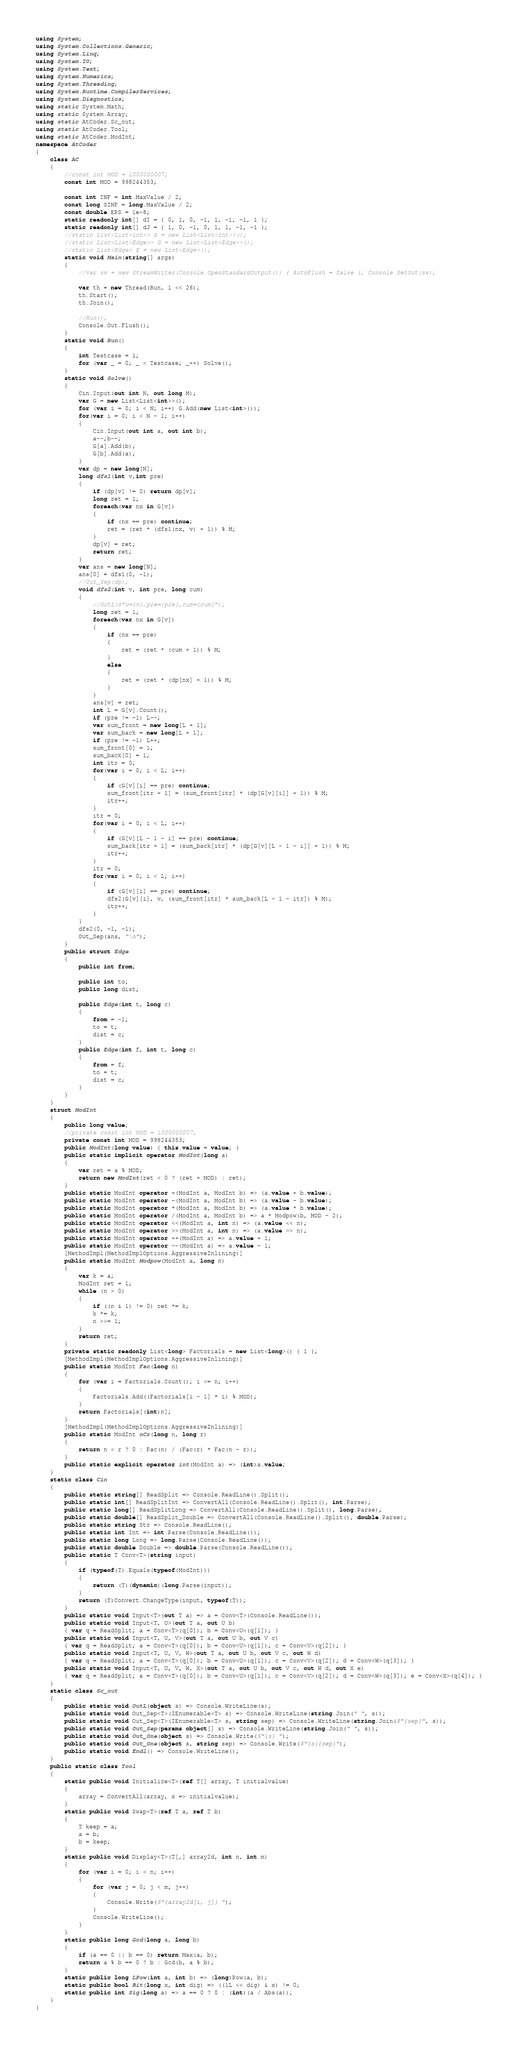Convert code to text. <code><loc_0><loc_0><loc_500><loc_500><_C#_>using System;
using System.Collections.Generic;
using System.Linq;
using System.IO;
using System.Text;
using System.Numerics;
using System.Threading;
using System.Runtime.CompilerServices;
using System.Diagnostics;
using static System.Math;
using static System.Array;
using static AtCoder.Sc_out;
using static AtCoder.Tool;
using static AtCoder.ModInt;
namespace AtCoder
{
    class AC
    {
        //const int MOD = 1000000007;
        const int MOD = 998244353;

        const int INF = int.MaxValue / 2;
        const long SINF = long.MaxValue / 2;
        const double EPS = 1e-8;
        static readonly int[] dI = { 0, 1, 0, -1, 1, -1, -1, 1 };
        static readonly int[] dJ = { 1, 0, -1, 0, 1, 1, -1, -1 };
        //static List<List<int>> G = new List<List<int>>();
        //static List<List<Edge>> G = new List<List<Edge>>();
        //static List<Edge> E = new List<Edge>();
        static void Main(string[] args)
        {
            //var sw = new StreamWriter(Console.OpenStandardOutput()) { AutoFlush = false }; Console.SetOut(sw);

            var th = new Thread(Run, 1 << 26);
            th.Start();
            th.Join();

            //Run();
            Console.Out.Flush();
        }
        static void Run()
        {
            int Testcase = 1;
            for (var _ = 0; _ < Testcase; _++) Solve();
        }
        static void Solve()
        {
            Cin.Input(out int N, out long M);
            var G = new List<List<int>>();
            for (var i = 0; i < N; i++) G.Add(new List<int>());
            for(var i = 0; i < N - 1; i++)
            {
                Cin.Input(out int a, out int b);
                a--;b--;
                G[a].Add(b);
                G[b].Add(a);
            }
            var dp = new long[N];
            long dfs1(int v,int pre)
            {
                if (dp[v] != 0) return dp[v];
                long ret = 1;
                foreach(var nx in G[v])
                {
                    if (nx == pre) continue;
                    ret = (ret * (dfs1(nx, v) + 1)) % M;
                }
                dp[v] = ret;
                return ret;
            }
            var ans = new long[N];
            ans[0] = dfs1(0, -1);
            //Out_Sep(dp);
            void dfs2(int v, int pre, long cum)
            {
                //OutL($"v={v},pre={pre},cum={cum}");
                long ret = 1;
                foreach(var nx in G[v])
                {
                    if (nx == pre)
                    {
                        ret = (ret * (cum + 1)) % M;
                    }
                    else
                    {
                        ret = (ret * (dp[nx] + 1)) % M;
                    }
                }
                ans[v] = ret;
                int L = G[v].Count();
                if (pre != -1) L--;
                var sum_front = new long[L + 1];
                var sum_back = new long[L + 1];
                if (pre != -1) L++;
                sum_front[0] = 1;
                sum_back[0] = 1;
                int itr = 0;
                for(var i = 0; i < L; i++)
                {
                    if (G[v][i] == pre) continue;
                    sum_front[itr + 1] = (sum_front[itr] * (dp[G[v][i]] + 1)) % M;
                    itr++;
                }
                itr = 0;
                for(var i = 0; i < L; i++)
                {
                    if (G[v][L - 1 - i] == pre) continue;
                    sum_back[itr + 1] = (sum_back[itr] * (dp[G[v][L - 1 - i]] + 1)) % M;
                    itr++;
                }
                itr = 0;
                for(var i = 0; i < L; i++)
                {
                    if (G[v][i] == pre) continue;
                    dfs2(G[v][i], v, (sum_front[itr] * sum_back[L - 1 - itr]) % M);
                    itr++;
                }
            }
            dfs2(0, -1, -1);
            Out_Sep(ans, "\n");
        }
        public struct Edge
        {
            public int from;

            public int to;
            public long dist;

            public Edge(int t, long c)
            {
                from = -1;
                to = t;
                dist = c;
            }
            public Edge(int f, int t, long c)
            {
                from = f;
                to = t;
                dist = c;
            }
        }
    }
    struct ModInt
    {
        public long value;
        //private const int MOD = 1000000007;
        private const int MOD = 998244353;
        public ModInt(long value) { this.value = value; }
        public static implicit operator ModInt(long a)
        {
            var ret = a % MOD;
            return new ModInt(ret < 0 ? (ret + MOD) : ret);
        }
        public static ModInt operator +(ModInt a, ModInt b) => (a.value + b.value);
        public static ModInt operator -(ModInt a, ModInt b) => (a.value - b.value);
        public static ModInt operator *(ModInt a, ModInt b) => (a.value * b.value);
        public static ModInt operator /(ModInt a, ModInt b) => a * Modpow(b, MOD - 2);
        public static ModInt operator <<(ModInt a, int n) => (a.value << n);
        public static ModInt operator >>(ModInt a, int n) => (a.value >> n);
        public static ModInt operator ++(ModInt a) => a.value + 1;
        public static ModInt operator --(ModInt a) => a.value - 1;
        [MethodImpl(MethodImplOptions.AggressiveInlining)]
        public static ModInt Modpow(ModInt a, long n)
        {
            var k = a;
            ModInt ret = 1;
            while (n > 0)
            {
                if ((n & 1) != 0) ret *= k;
                k *= k;
                n >>= 1;
            }
            return ret;
        }
        private static readonly List<long> Factorials = new List<long>() { 1 };
        [MethodImpl(MethodImplOptions.AggressiveInlining)]
        public static ModInt Fac(long n)
        {
            for (var i = Factorials.Count(); i <= n; i++)
            {
                Factorials.Add((Factorials[i - 1] * i) % MOD);
            }
            return Factorials[(int)n];
        }
        [MethodImpl(MethodImplOptions.AggressiveInlining)]
        public static ModInt nCr(long n, long r)
        {
            return n < r ? 0 : Fac(n) / (Fac(r) * Fac(n - r));
        }
        public static explicit operator int(ModInt a) => (int)a.value;
    }
    static class Cin
    {
        public static string[] ReadSplit => Console.ReadLine().Split();
        public static int[] ReadSplitInt => ConvertAll(Console.ReadLine().Split(), int.Parse);
        public static long[] ReadSplitLong => ConvertAll(Console.ReadLine().Split(), long.Parse);
        public static double[] ReadSplit_Double => ConvertAll(Console.ReadLine().Split(), double.Parse);
        public static string Str => Console.ReadLine();
        public static int Int => int.Parse(Console.ReadLine());
        public static long Long => long.Parse(Console.ReadLine());
        public static double Double => double.Parse(Console.ReadLine());
        public static T Conv<T>(string input)
        {
            if (typeof(T).Equals(typeof(ModInt)))
            {
                return (T)(dynamic)(long.Parse(input));
            }
            return (T)Convert.ChangeType(input, typeof(T));
        }
        public static void Input<T>(out T a) => a = Conv<T>(Console.ReadLine());
        public static void Input<T, U>(out T a, out U b)
        { var q = ReadSplit; a = Conv<T>(q[0]); b = Conv<U>(q[1]); }
        public static void Input<T, U, V>(out T a, out U b, out V c)
        { var q = ReadSplit; a = Conv<T>(q[0]); b = Conv<U>(q[1]); c = Conv<V>(q[2]); }
        public static void Input<T, U, V, W>(out T a, out U b, out V c, out W d)
        { var q = ReadSplit; a = Conv<T>(q[0]); b = Conv<U>(q[1]); c = Conv<V>(q[2]); d = Conv<W>(q[3]); }
        public static void Input<T, U, V, W, X>(out T a, out U b, out V c, out W d, out X e)
        { var q = ReadSplit; a = Conv<T>(q[0]); b = Conv<U>(q[1]); c = Conv<V>(q[2]); d = Conv<W>(q[3]); e = Conv<X>(q[4]); }
    }
    static class Sc_out
    {
        public static void OutL(object s) => Console.WriteLine(s);
        public static void Out_Sep<T>(IEnumerable<T> s) => Console.WriteLine(string.Join(" ", s));
        public static void Out_Sep<T>(IEnumerable<T> s, string sep) => Console.WriteLine(string.Join($"{sep}", s));
        public static void Out_Sep(params object[] s) => Console.WriteLine(string.Join(" ", s));
        public static void Out_One(object s) => Console.Write($"{s} ");
        public static void Out_One(object s, string sep) => Console.Write($"{s}{sep}");
        public static void Endl() => Console.WriteLine();
    }
    public static class Tool
    {
        static public void Initialize<T>(ref T[] array, T initialvalue)
        {
            array = ConvertAll(array, x => initialvalue);
        }
        static public void Swap<T>(ref T a, ref T b)
        {
            T keep = a;
            a = b;
            b = keep;
        }
        static public void Display<T>(T[,] array2d, int n, int m)
        {
            for (var i = 0; i < n; i++)
            {
                for (var j = 0; j < m; j++)
                {
                    Console.Write($"{array2d[i, j]} ");
                }
                Console.WriteLine();
            }
        }
        static public long Gcd(long a, long b)
        {
            if (a == 0 || b == 0) return Max(a, b);
            return a % b == 0 ? b : Gcd(b, a % b);
        }
        static public long LPow(int a, int b) => (long)Pow(a, b);
        static public bool Bit(long x, int dig) => ((1L << dig) & x) != 0;
        static public int Sig(long a) => a == 0 ? 0 : (int)(a / Abs(a));
    }
}
</code> 